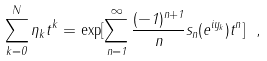Convert formula to latex. <formula><loc_0><loc_0><loc_500><loc_500>\sum _ { k = 0 } ^ { N } \eta _ { k } t ^ { k } = \exp [ \sum _ { n = 1 } ^ { \infty } \frac { ( - 1 ) ^ { n + 1 } } { n } s _ { n } ( e ^ { i y _ { k } } ) t ^ { n } ] \ ,</formula> 